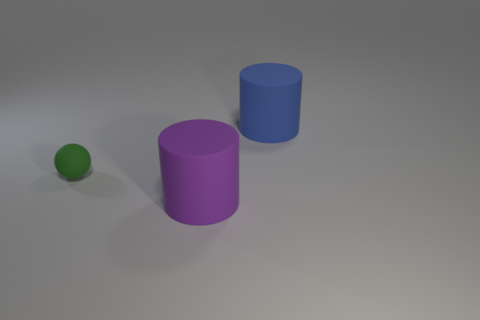Add 2 purple matte objects. How many objects exist? 5 Subtract all spheres. How many objects are left? 2 Add 1 brown metallic balls. How many brown metallic balls exist? 1 Subtract 0 yellow cubes. How many objects are left? 3 Subtract all small rubber things. Subtract all cylinders. How many objects are left? 0 Add 1 big blue matte objects. How many big blue matte objects are left? 2 